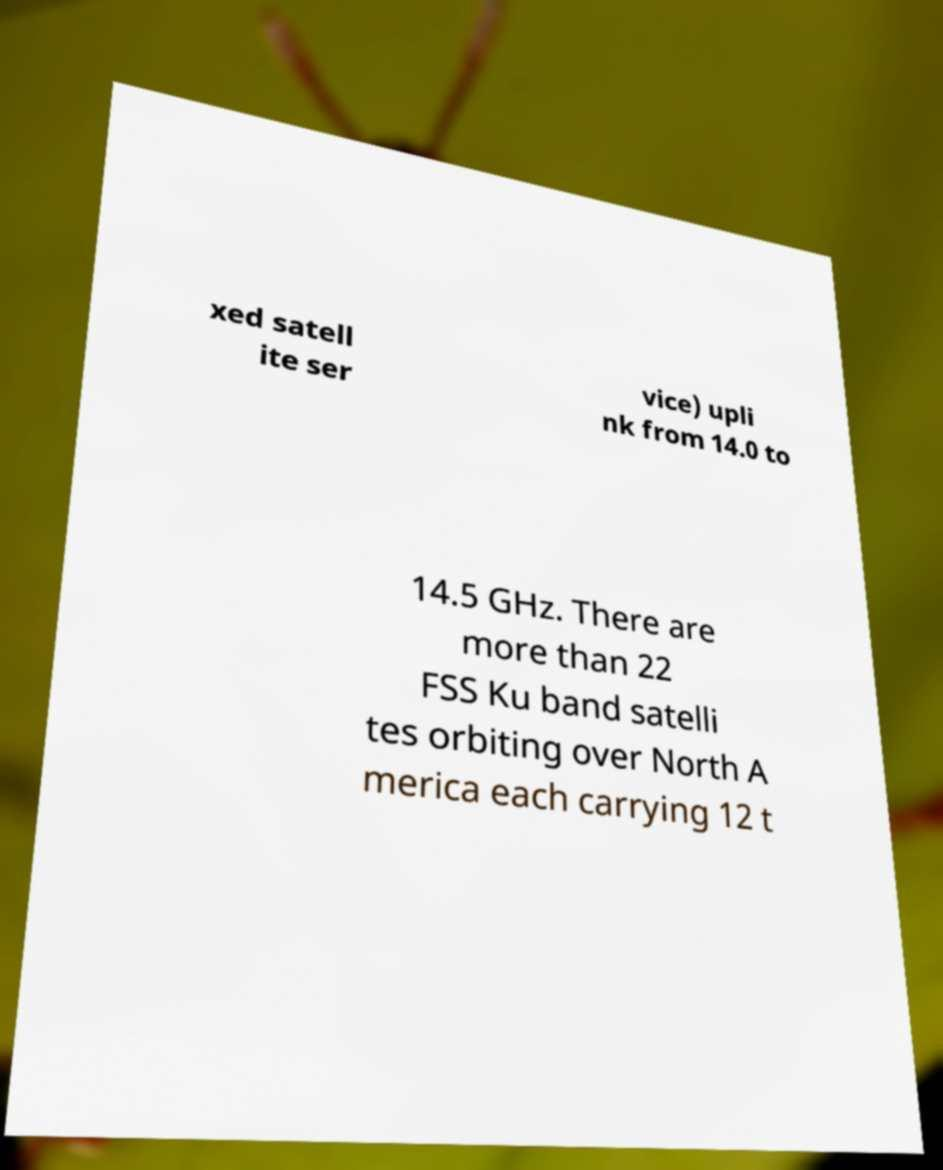Can you accurately transcribe the text from the provided image for me? xed satell ite ser vice) upli nk from 14.0 to 14.5 GHz. There are more than 22 FSS Ku band satelli tes orbiting over North A merica each carrying 12 t 